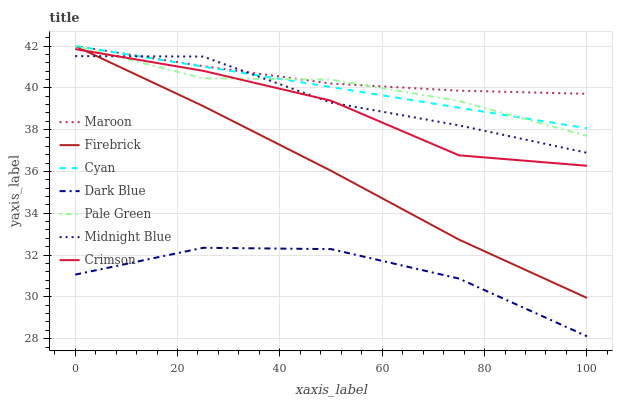Does Dark Blue have the minimum area under the curve?
Answer yes or no. Yes. Does Maroon have the maximum area under the curve?
Answer yes or no. Yes. Does Firebrick have the minimum area under the curve?
Answer yes or no. No. Does Firebrick have the maximum area under the curve?
Answer yes or no. No. Is Cyan the smoothest?
Answer yes or no. Yes. Is Dark Blue the roughest?
Answer yes or no. Yes. Is Firebrick the smoothest?
Answer yes or no. No. Is Firebrick the roughest?
Answer yes or no. No. Does Firebrick have the lowest value?
Answer yes or no. No. Does Cyan have the highest value?
Answer yes or no. Yes. Does Dark Blue have the highest value?
Answer yes or no. No. Is Dark Blue less than Firebrick?
Answer yes or no. Yes. Is Cyan greater than Dark Blue?
Answer yes or no. Yes. Does Firebrick intersect Midnight Blue?
Answer yes or no. Yes. Is Firebrick less than Midnight Blue?
Answer yes or no. No. Is Firebrick greater than Midnight Blue?
Answer yes or no. No. Does Dark Blue intersect Firebrick?
Answer yes or no. No. 